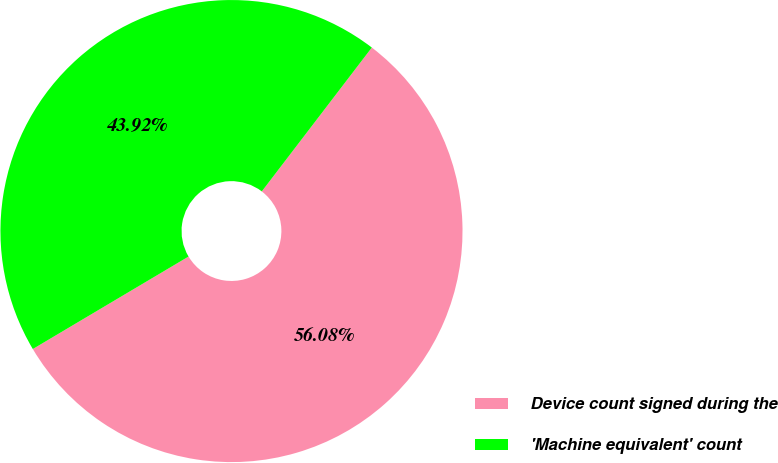Convert chart. <chart><loc_0><loc_0><loc_500><loc_500><pie_chart><fcel>Device count signed during the<fcel>'Machine equivalent' count<nl><fcel>56.08%<fcel>43.92%<nl></chart> 